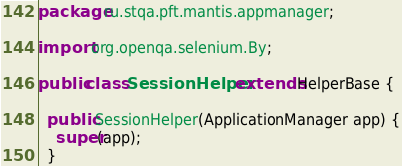Convert code to text. <code><loc_0><loc_0><loc_500><loc_500><_Java_>package ru.stqa.pft.mantis.appmanager;

import org.openqa.selenium.By;

public class SessionHelper extends HelperBase {

  public SessionHelper(ApplicationManager app) {
    super(app);
  }
</code> 